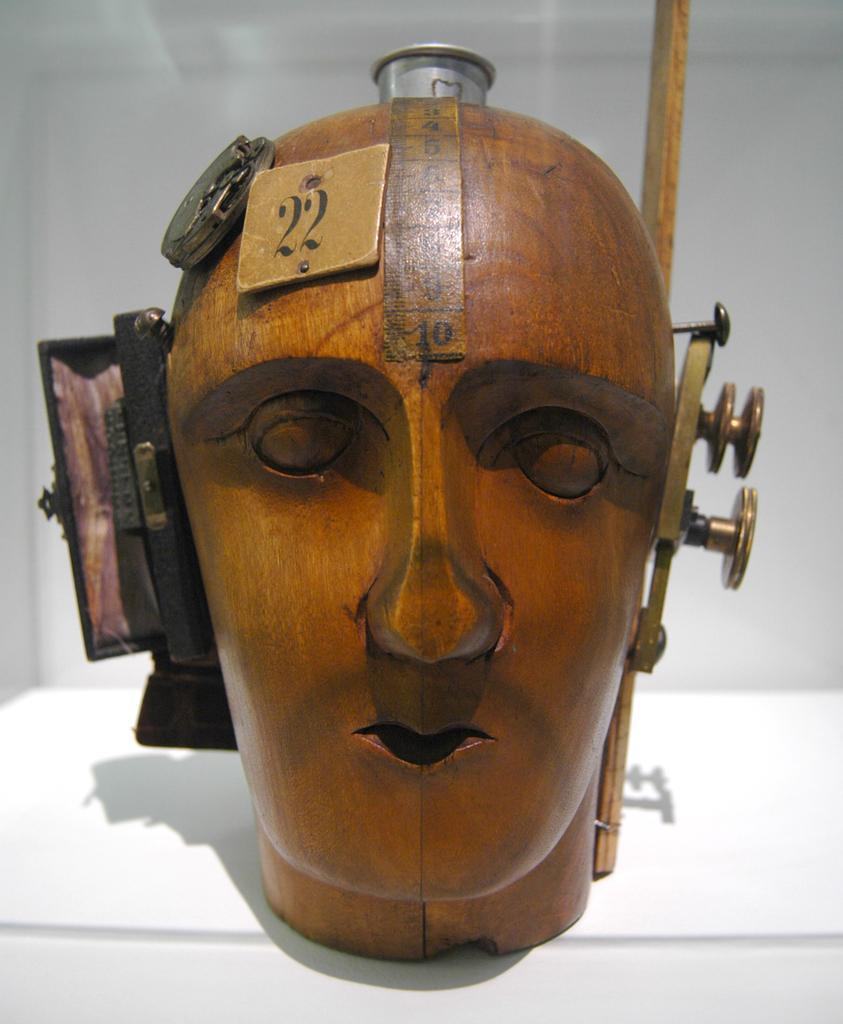What material is the machine in the image made of? The machine is made of wood. What is the appearance of the wooden machine? The wooden machine is carved to resemble a human face. What can be seen attached to the wooden machine? There are objects attached to the wooden machine. What color is the background in the image? The background appears to be white in color. How many feathers can be seen on the wooden machine in the image? There are no feathers present on the wooden machine in the image. What type of page is visible in the background of the image? There is no page visible in the background of the image. 